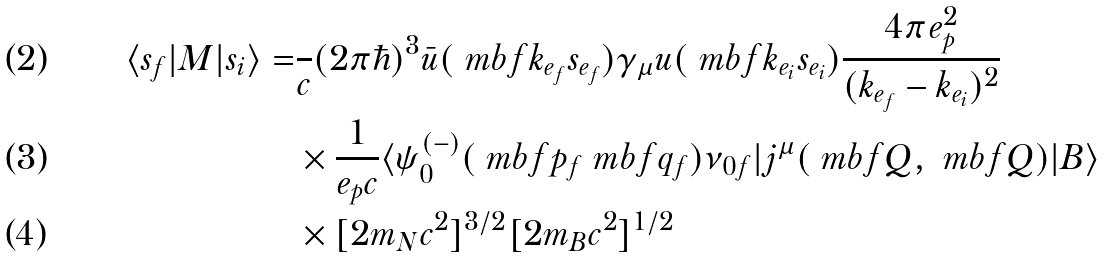Convert formula to latex. <formula><loc_0><loc_0><loc_500><loc_500>\langle s _ { f } | M | s _ { i } \rangle = & \frac { } { c } ( 2 \pi \hbar { ) } ^ { 3 } \bar { u } ( \ m b f { k } _ { e _ { f } } s _ { e _ { f } } ) \gamma _ { \mu } u ( \ m b f { k } _ { e _ { i } } s _ { e _ { i } } ) \frac { 4 \pi e _ { p } ^ { 2 } } { ( k _ { e _ { f } } - k _ { e _ { i } } ) ^ { 2 } } \\ & \times \frac { 1 } { e _ { p } c } \langle \psi ^ { ( - ) } _ { 0 } ( \ m b f { p } _ { f } \ m b f { q } _ { f } ) \nu _ { 0 f } | j ^ { \mu } ( \ m b f { Q } , \ m b f { Q } ) | B \rangle \\ & \times [ 2 m _ { N } c ^ { 2 } ] ^ { 3 / 2 } [ 2 m _ { B } c ^ { 2 } ] ^ { 1 / 2 }</formula> 